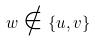Convert formula to latex. <formula><loc_0><loc_0><loc_500><loc_500>w \notin \{ u , v \}</formula> 